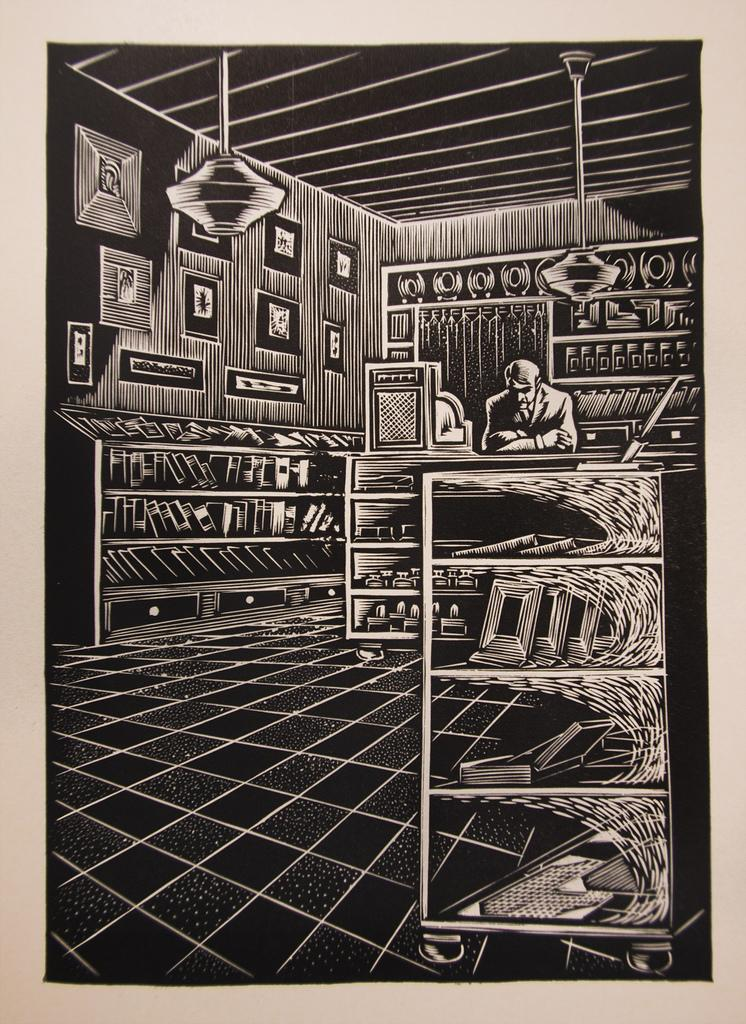Provide a one-sentence caption for the provided image. A sketch of a man in behind the counter in a bookshop has no text in the drawing. 